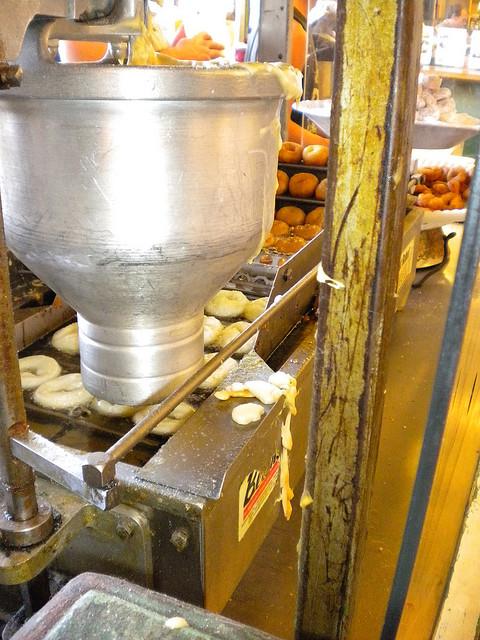Is this edible object high in sugar?
Give a very brief answer. Yes. What is coming out of the press?
Write a very short answer. Donuts. What type of metal is this?
Concise answer only. Aluminum. 